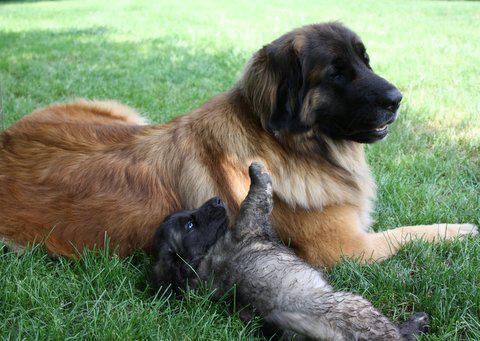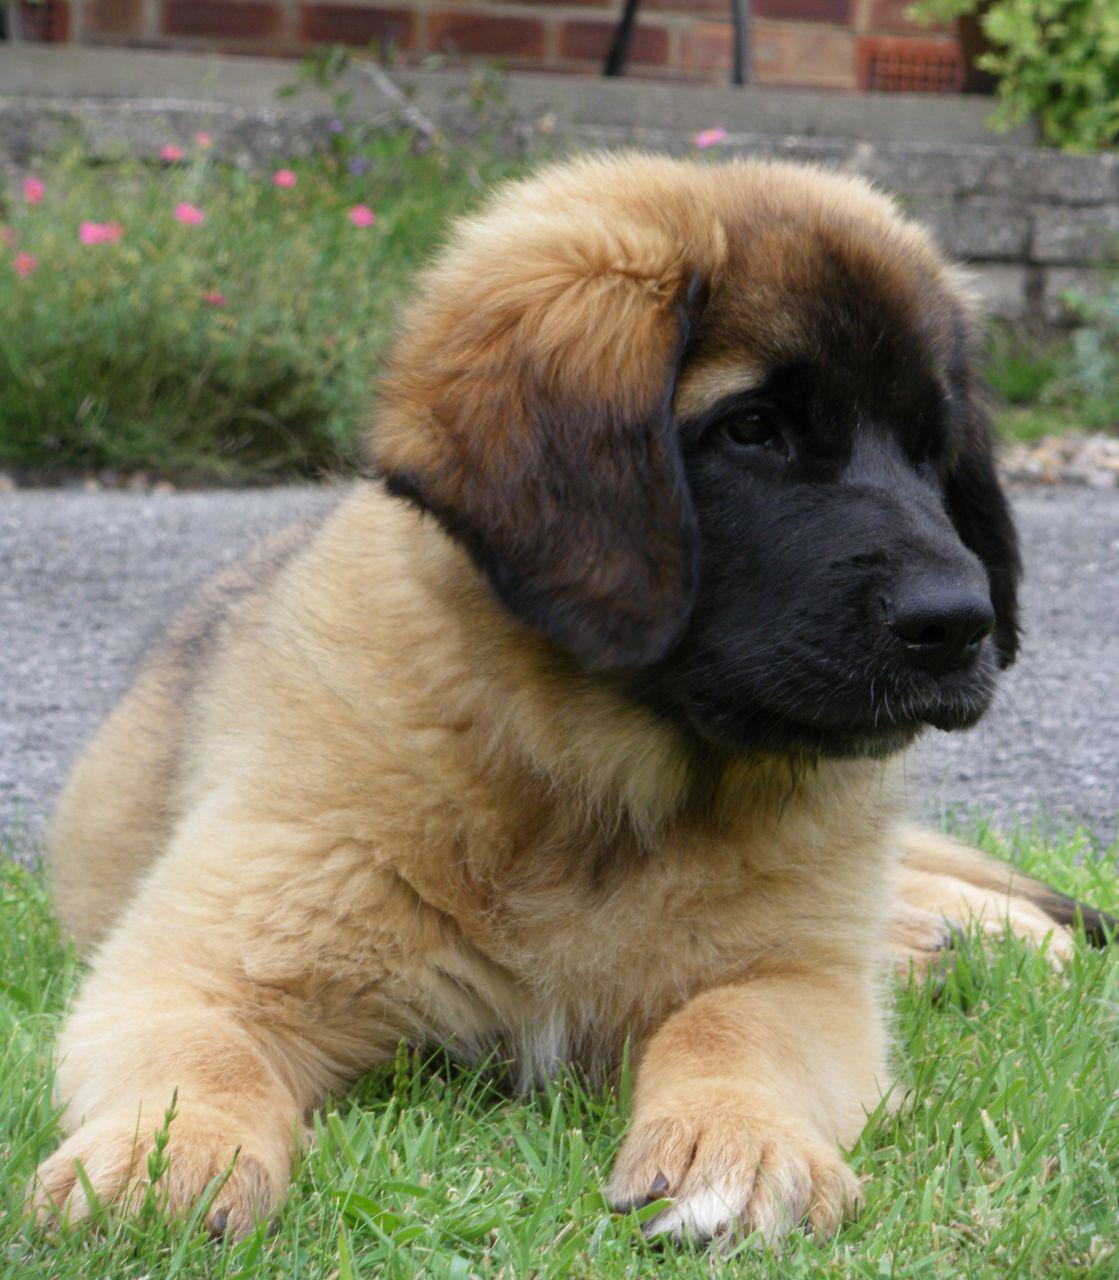The first image is the image on the left, the second image is the image on the right. For the images displayed, is the sentence "There are at most three dogs." factually correct? Answer yes or no. Yes. 